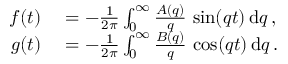Convert formula to latex. <formula><loc_0><loc_0><loc_500><loc_500>\begin{array} { r l } { f ( t ) } & = - \frac { 1 } { 2 \pi } \int _ { 0 } ^ { \infty } \frac { A ( q ) } { q } \, \sin ( q t ) \, d q \, , } \\ { g ( t ) } & = - \frac { 1 } { 2 \pi } \int _ { 0 } ^ { \infty } \frac { B ( q ) } { q } \, \cos ( q t ) \, d q \, . } \end{array}</formula> 